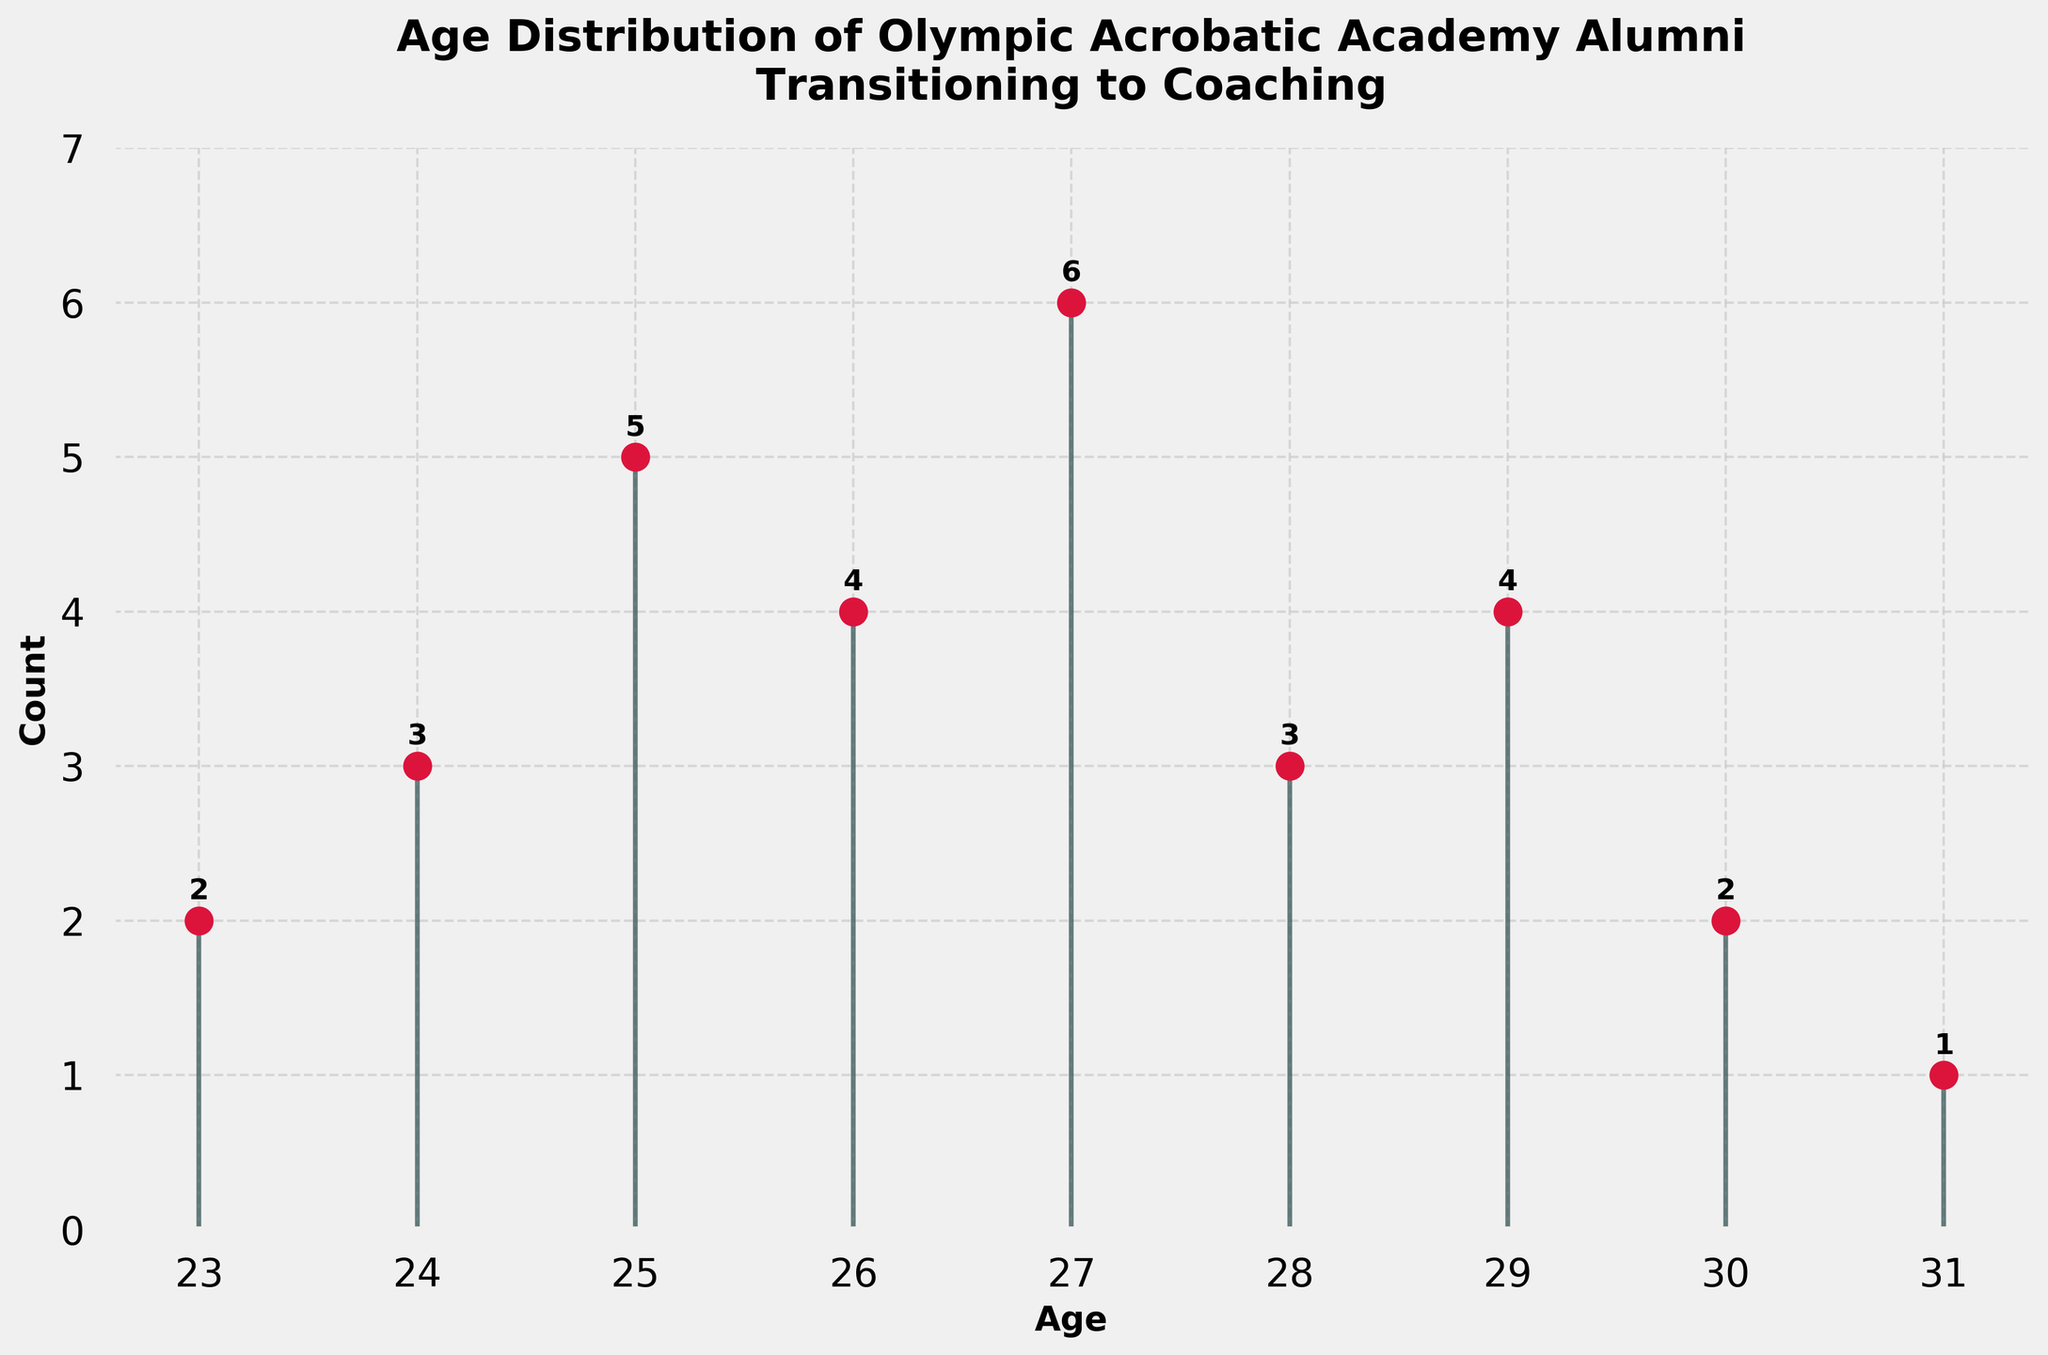What is the title of the figure? The title of the figure is the text displayed at the top. From the description, the title clearly states: "Age Distribution of Olympic Acrobatic Academy Alumni Transitioning to Coaching".
Answer: Age Distribution of Olympic Acrobatic Academy Alumni Transitioning to Coaching What is the age range of the alumni who transitioned to coaching? The age range can be identified by looking at the x-axis, which specifies the ages. The smallest age is 23 and the largest is 31.
Answer: 23 to 31 Which age group has the highest count of alumni transitioning to coaching? To find the highest count, look at the stem with the longest length. The stem corresponding to age 27 has the highest count of 6.
Answer: 27 How many alumni transitioned to coaching at the age of 30? Look for the stem corresponding to age 30. The height of that stem, as well as the number above it, indicate the count. For age 30, the count is 2.
Answer: 2 What is the combined total of alumni transitioning to coaching ages 25 and 26? To find the combined total, add the counts for ages 25 and 26. Age 25 has 5 alumni and age 26 has 4 alumni, thus 5 + 4 = 9.
Answer: 9 Between age 24 and age 29, which age has the smallest number of alumni transitioning to coaching? Compare each count between ages 24 and 29. Age 24 has 3, 25 has 5, 26 has 4, 27 has 6, 28 has 3, 29 has 4. The smallest number is at age 24 and age 28, both having 3 alumni.
Answer: 24 and 28 Are there more alumni transitioning to coaching at age 23 or age 31? Compare the counts for ages 23 and 31. Age 23 has 2 alumni while age 31 has 1. Hence, age 23 has more alumni transitioning.
Answer: 23 What is the total number of alumni transitioning to coaching across all ages? Sum up the counts from all age groups: 2 (age 23) + 3 (age 24) + 5 (age 25) + 4 (age 26) + 6 (age 27) + 3 (age 28) + 4 (age 29) + 2 (age 30) + 1 (age 31) = 30.
Answer: 30 What age has the same number of alumni transitioning to coaching as age 26? From the figure, the count at age 26 is 4. You need to find another age with the same count. Age 29 also has 4 alumni transitioning to coaching.
Answer: 29 